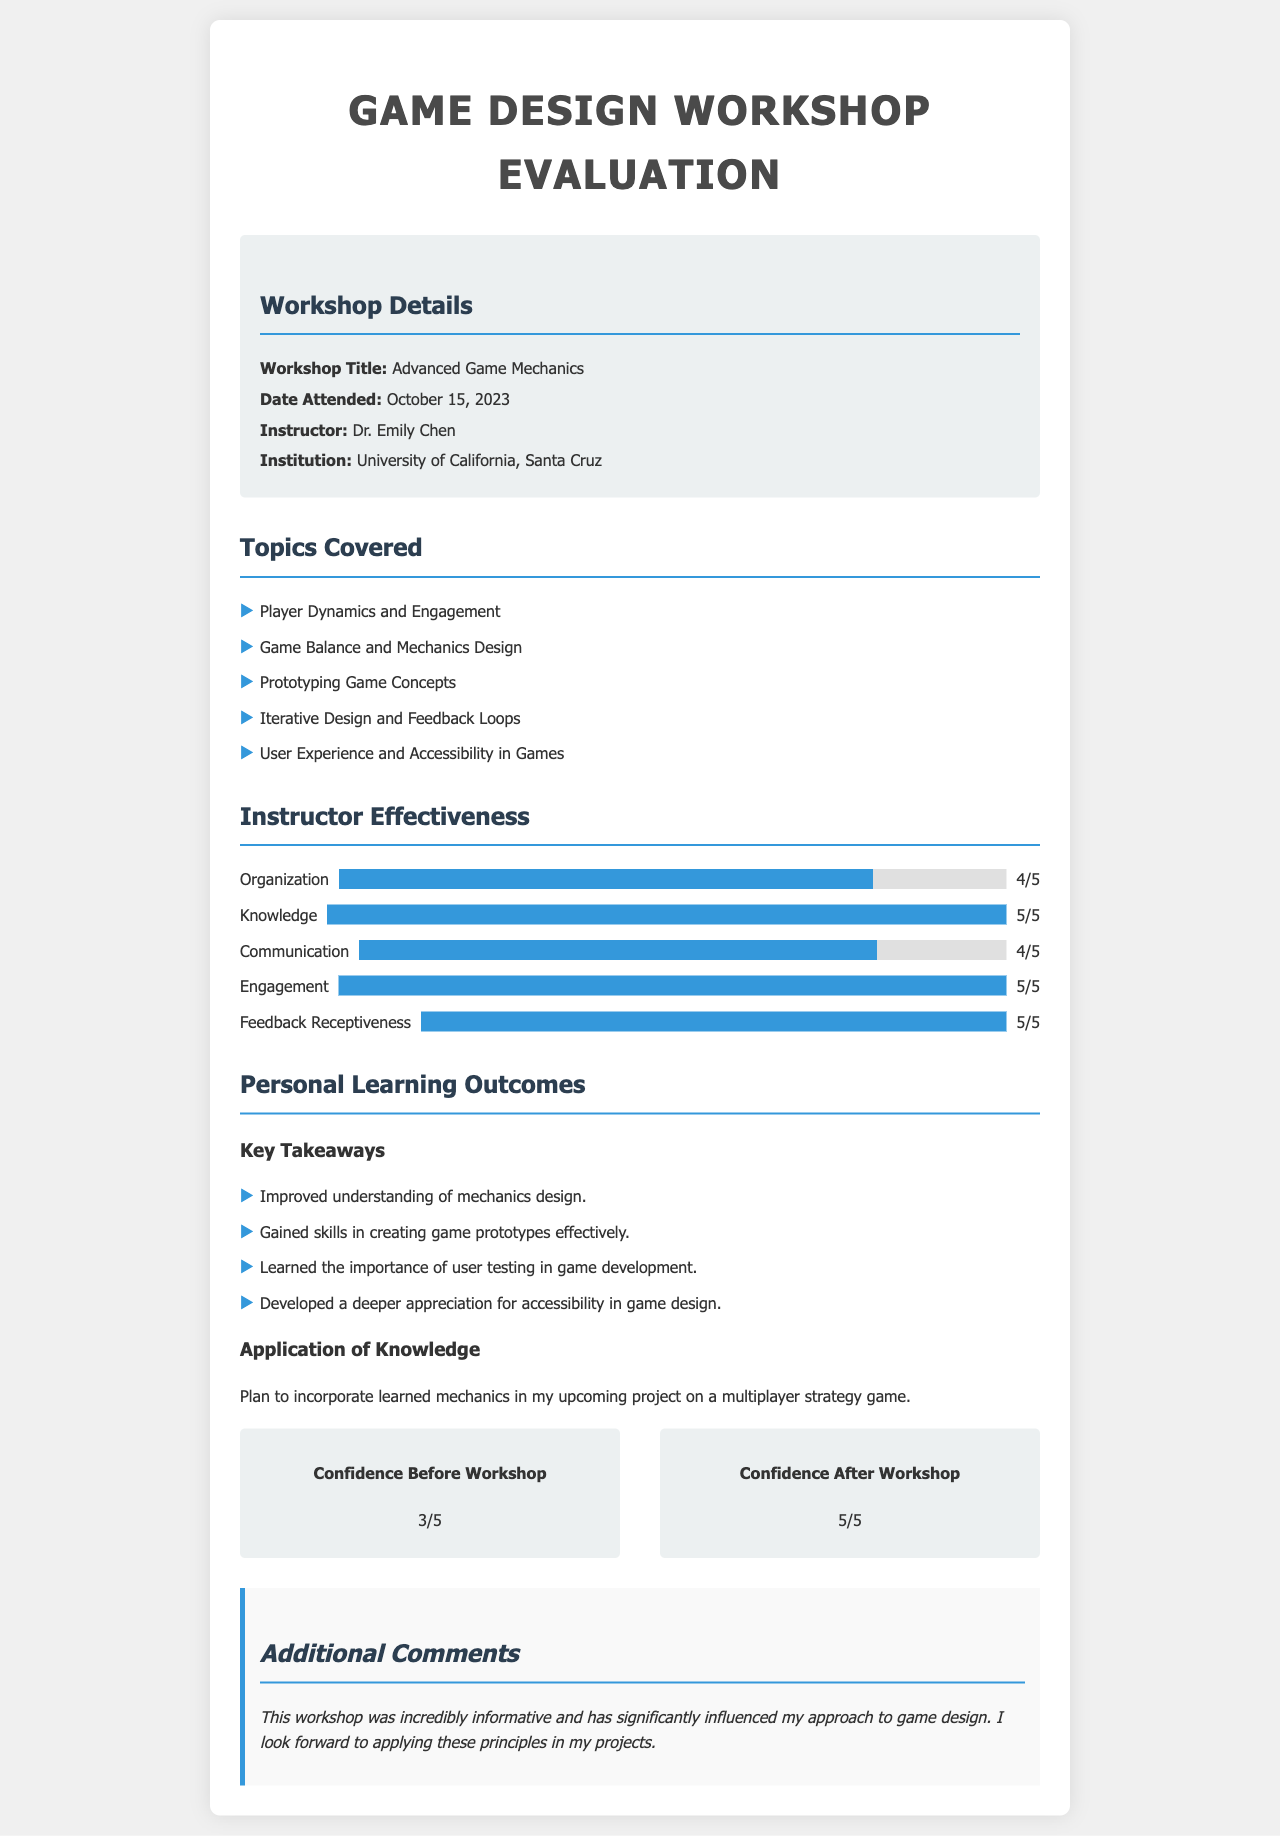What is the title of the workshop? The title is found in the workshop details section and is explicitly stated as "Advanced Game Mechanics."
Answer: Advanced Game Mechanics Who was the instructor for the workshop? The instructor's name is mentioned in the workshop details and is "Dr. Emily Chen."
Answer: Dr. Emily Chen On what date was the workshop attended? The attended date is documented in the workshop details, which states "October 15, 2023."
Answer: October 15, 2023 What rating did the instructor receive for Knowledge? The rating for Knowledge is found in the instructor effectiveness section, where it states "5/5."
Answer: 5/5 How many topics were covered in the workshop? By counting the list of topics covered, which contains five items, we can determine the total number of topics.
Answer: 5 What was the confidence level before the workshop? The confidence level before the workshop is provided in the confidence level section as "3/5."
Answer: 3/5 What is one key takeaway mentioned for personal learning outcomes? The document lists "Improved understanding of mechanics design" as one of the key takeaways.
Answer: Improved understanding of mechanics design What was the feedback rating for Engagement? The feedback rating for Engagement is specified in the instructor effectiveness section as "5/5."
Answer: 5/5 What application of knowledge is mentioned in the workshop evaluation? The application of knowledge is succinctly stated as a plan to "incorporate learned mechanics in my upcoming project on a multiplayer strategy game."
Answer: incorporate learned mechanics in my upcoming project on a multiplayer strategy game 